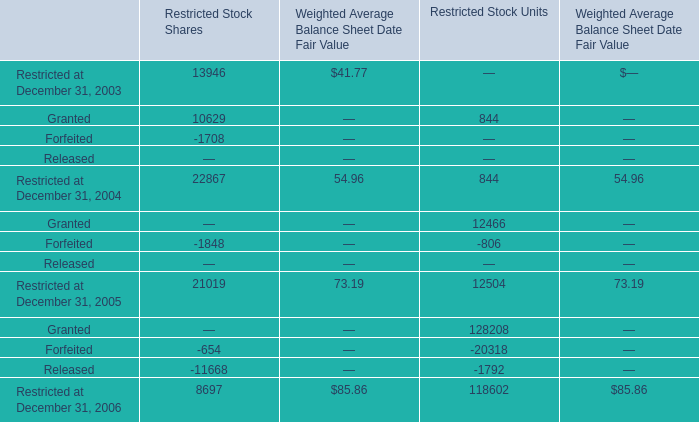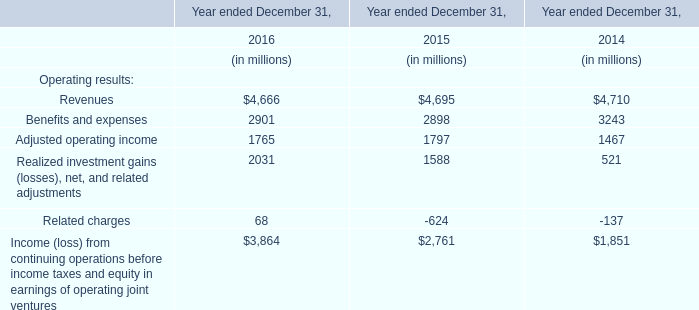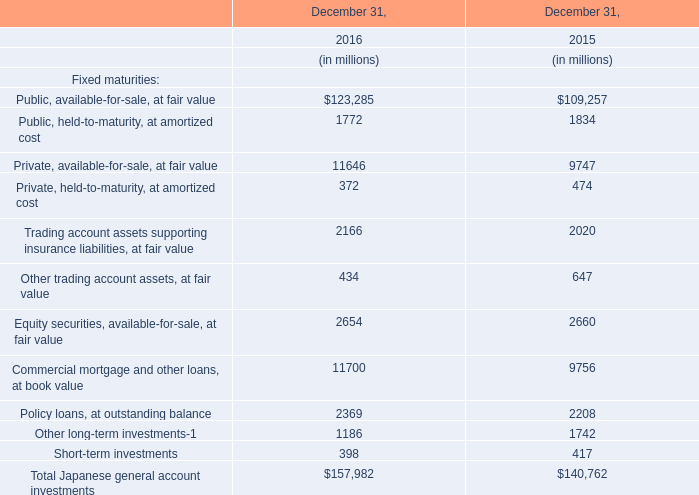Does the value of Restricted at December 31, 2003 for Restricted Stock Shares in 2003 greater than that in 2004 ? 
Answer: No. 